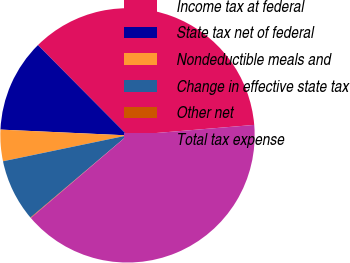<chart> <loc_0><loc_0><loc_500><loc_500><pie_chart><fcel>Income tax at federal<fcel>State tax net of federal<fcel>Nondeductible meals and<fcel>Change in effective state tax<fcel>Other net<fcel>Total tax expense<nl><fcel>36.12%<fcel>11.84%<fcel>3.99%<fcel>7.92%<fcel>0.07%<fcel>40.05%<nl></chart> 